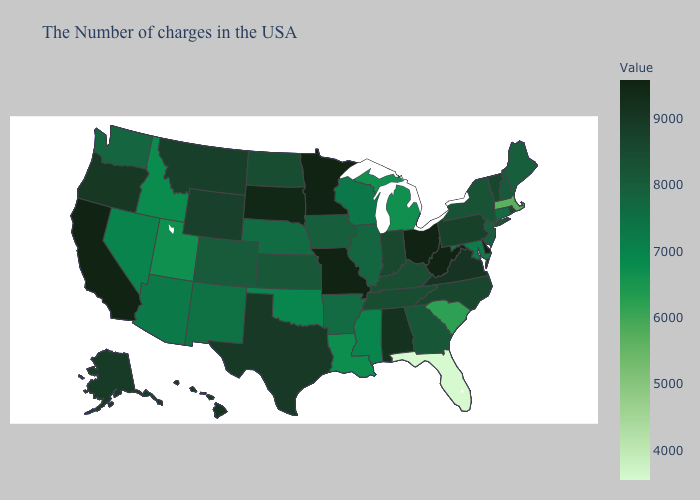Does Connecticut have the highest value in the Northeast?
Quick response, please. No. Which states have the highest value in the USA?
Keep it brief. Delaware, West Virginia, Ohio, Missouri, Minnesota, California. Which states have the highest value in the USA?
Be succinct. Delaware, West Virginia, Ohio, Missouri, Minnesota, California. Does Rhode Island have the highest value in the USA?
Keep it brief. No. Among the states that border Wisconsin , does Illinois have the highest value?
Quick response, please. No. Does Utah have the lowest value in the West?
Write a very short answer. Yes. Which states have the highest value in the USA?
Give a very brief answer. Delaware, West Virginia, Ohio, Missouri, Minnesota, California. Which states have the highest value in the USA?
Keep it brief. Delaware, West Virginia, Ohio, Missouri, Minnesota, California. 